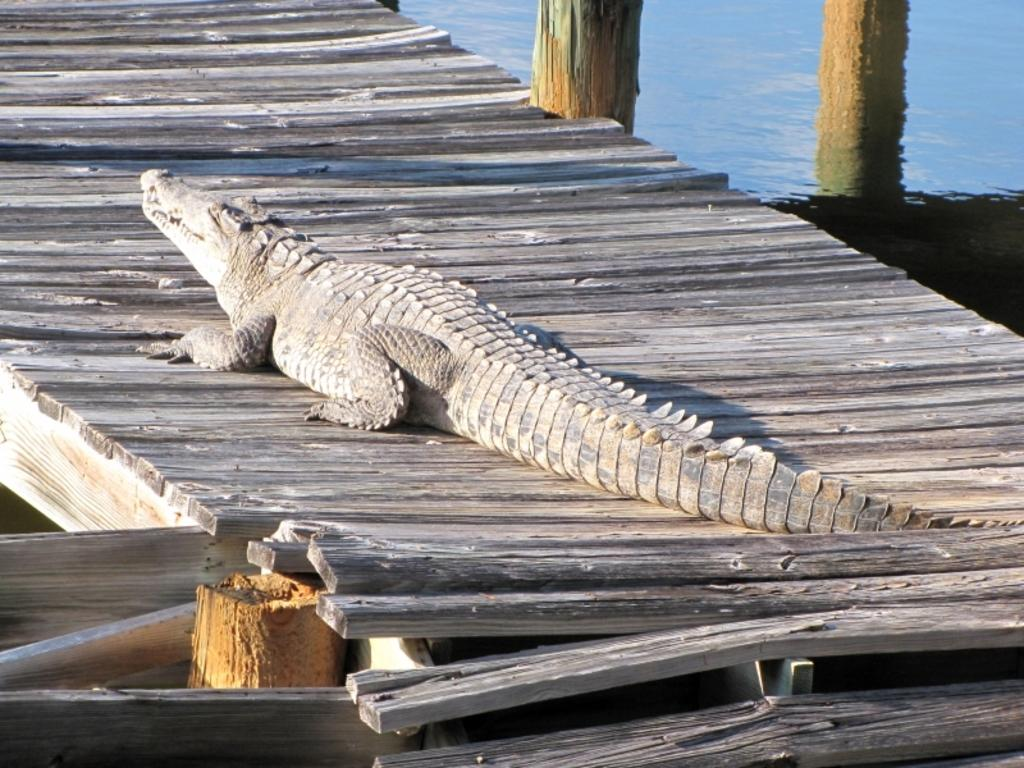Where was the image taken? The image was clicked outside the city. What is the main subject in the image? There is a crocodile in the center of the image. What is the crocodile resting on? The crocodile is on wooden planks. What can be seen in the background of the image? There is a water body and poles in the background of the image. What type of tomatoes are being discussed by the committee in the image? There is no committee or discussion about tomatoes in the image; it features a crocodile on wooden planks with a water body and poles in the background. 